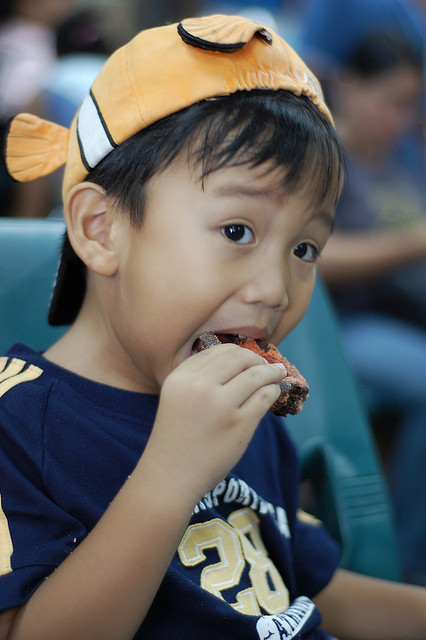Read and extract the text from this image. P DAY 28 AT 